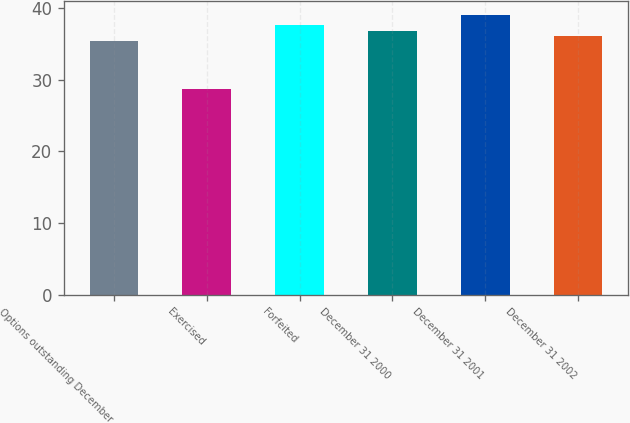<chart> <loc_0><loc_0><loc_500><loc_500><bar_chart><fcel>Options outstanding December<fcel>Exercised<fcel>Forfeited<fcel>December 31 2000<fcel>December 31 2001<fcel>December 31 2002<nl><fcel>35.37<fcel>28.65<fcel>37.59<fcel>36.85<fcel>39.07<fcel>36.11<nl></chart> 